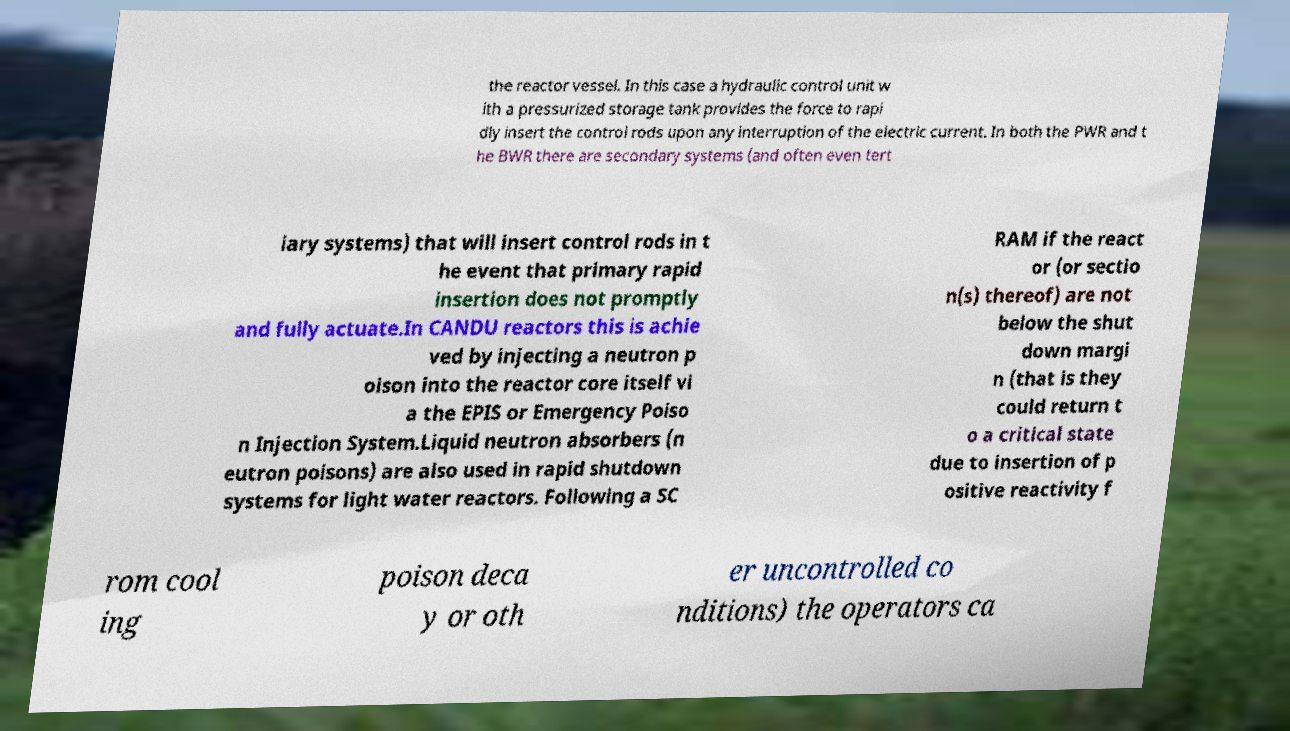Could you assist in decoding the text presented in this image and type it out clearly? the reactor vessel. In this case a hydraulic control unit w ith a pressurized storage tank provides the force to rapi dly insert the control rods upon any interruption of the electric current. In both the PWR and t he BWR there are secondary systems (and often even tert iary systems) that will insert control rods in t he event that primary rapid insertion does not promptly and fully actuate.In CANDU reactors this is achie ved by injecting a neutron p oison into the reactor core itself vi a the EPIS or Emergency Poiso n Injection System.Liquid neutron absorbers (n eutron poisons) are also used in rapid shutdown systems for light water reactors. Following a SC RAM if the react or (or sectio n(s) thereof) are not below the shut down margi n (that is they could return t o a critical state due to insertion of p ositive reactivity f rom cool ing poison deca y or oth er uncontrolled co nditions) the operators ca 